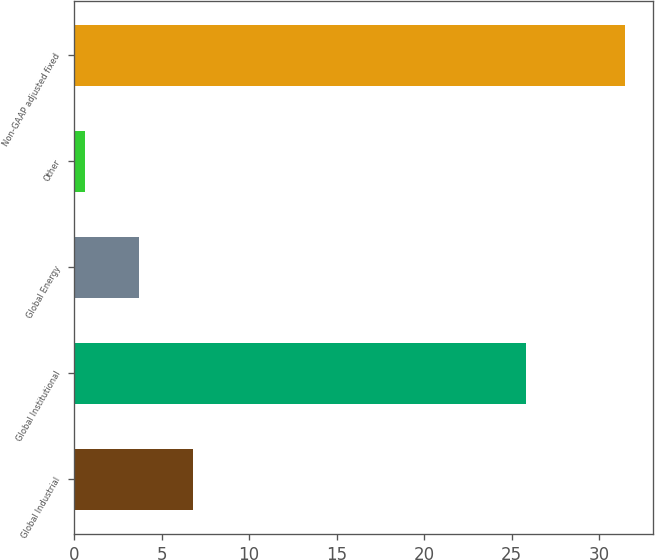Convert chart to OTSL. <chart><loc_0><loc_0><loc_500><loc_500><bar_chart><fcel>Global Industrial<fcel>Global Institutional<fcel>Global Energy<fcel>Other<fcel>Non-GAAP adjusted fixed<nl><fcel>6.78<fcel>25.8<fcel>3.69<fcel>0.6<fcel>31.5<nl></chart> 